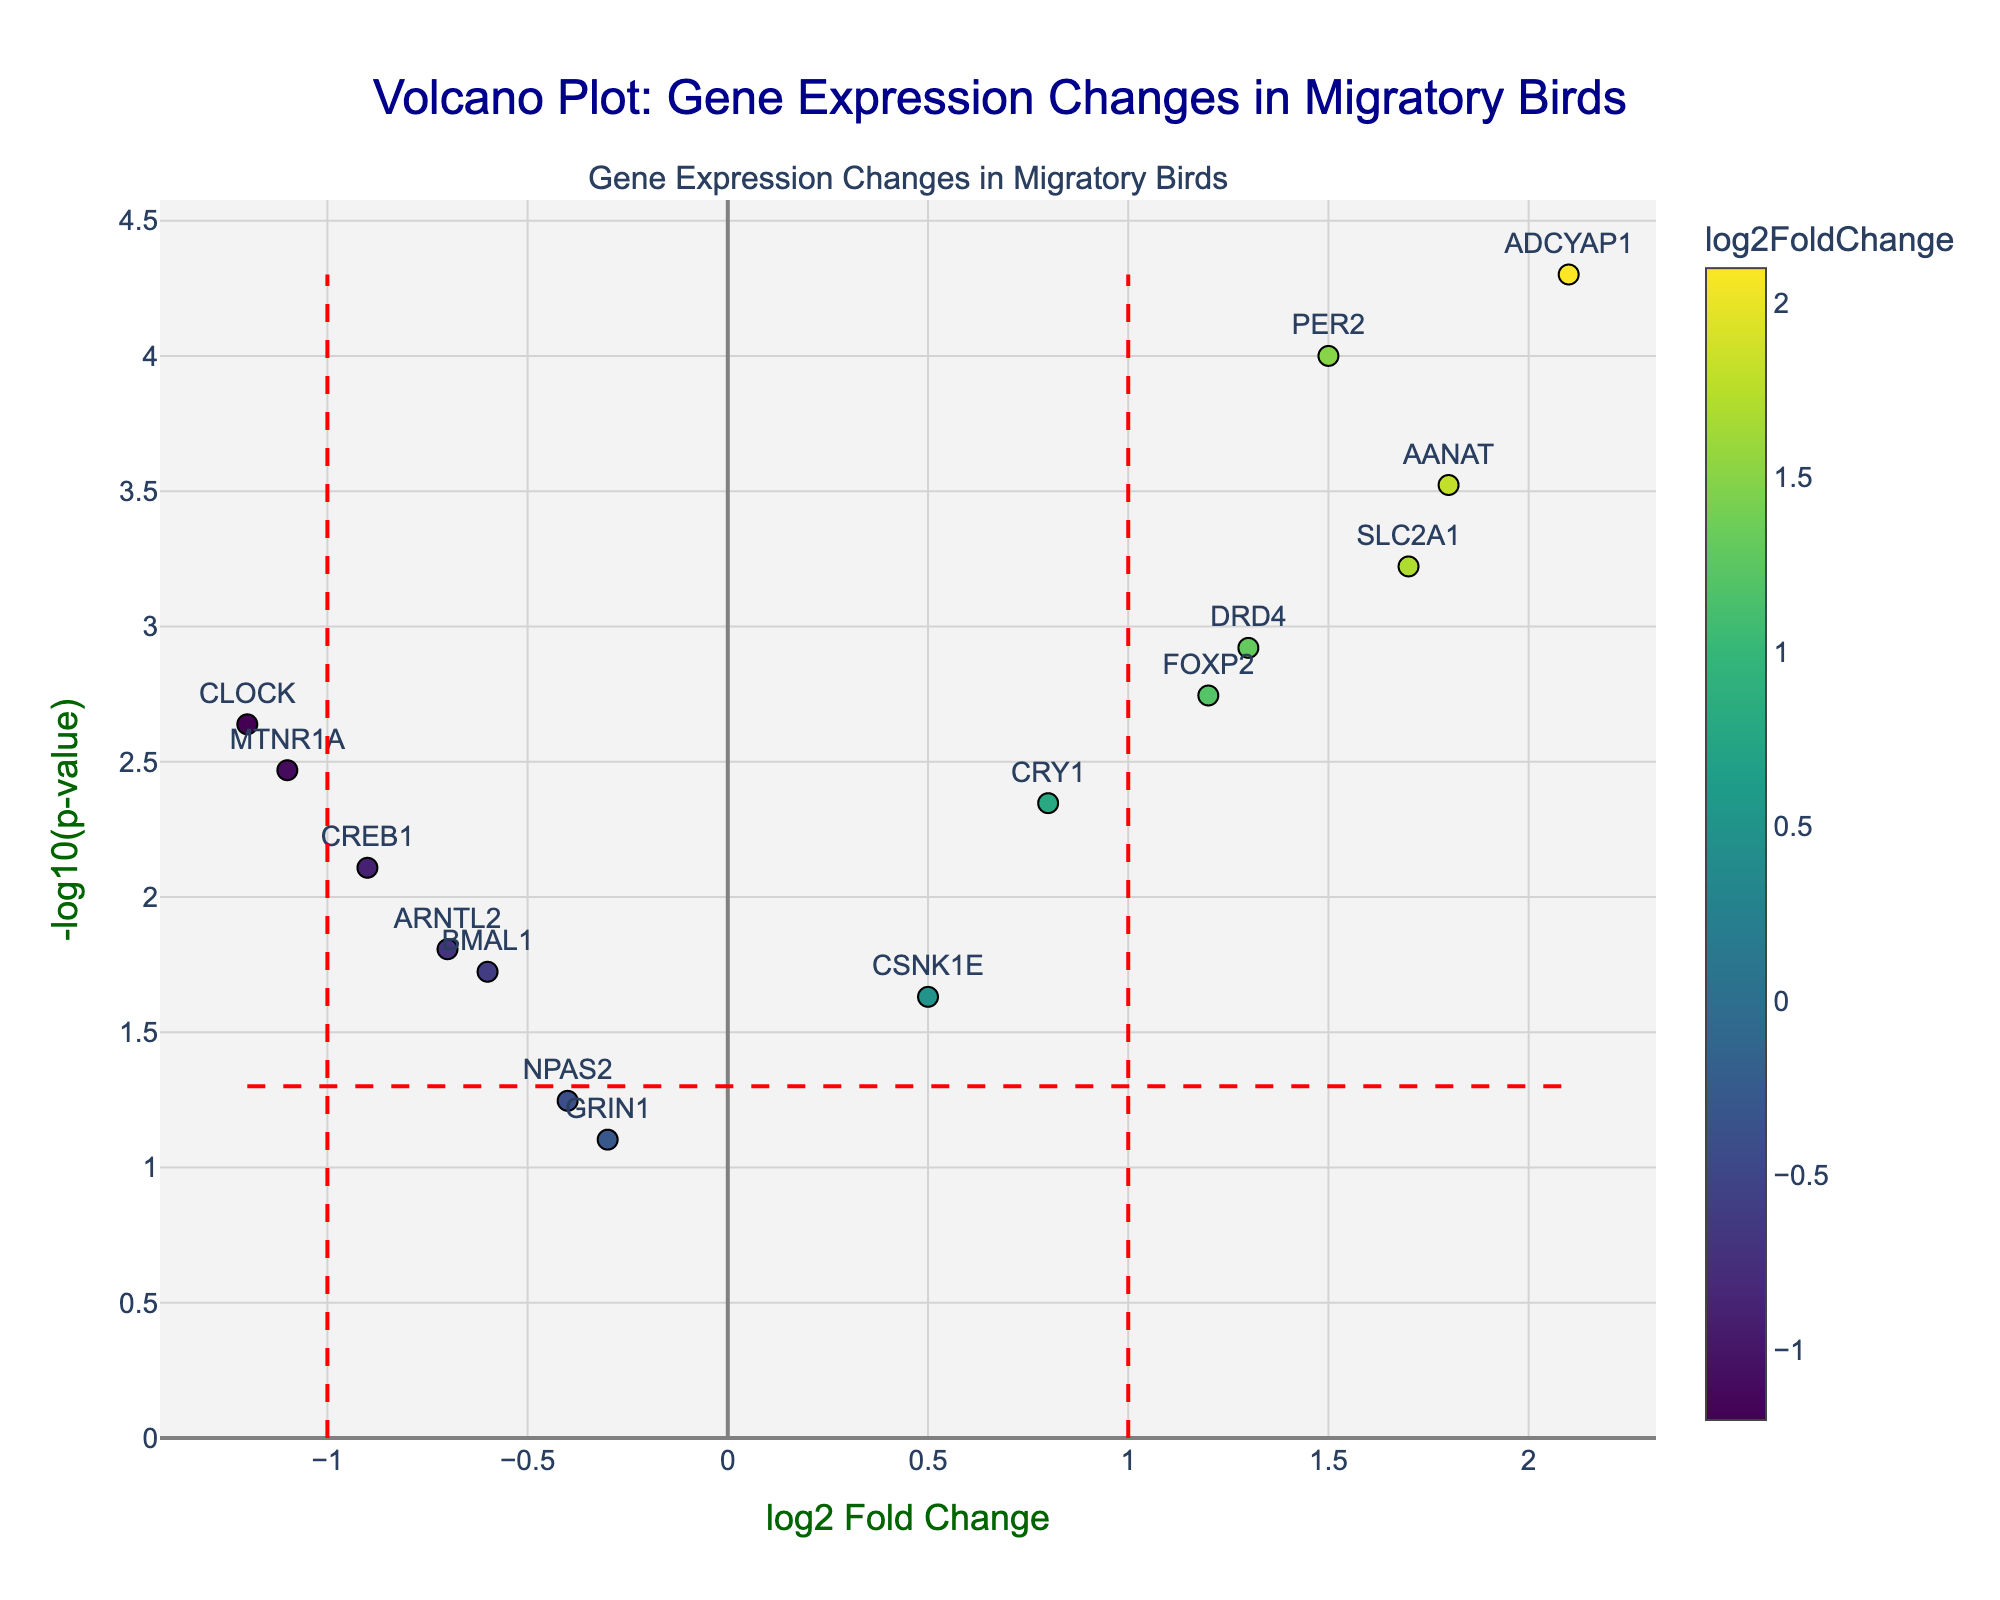How many genes have a log2 fold change greater than 1 or less than -1? Identify the data points where log2 fold change (x-axis) is either greater than 1 or less than -1. There are two vertical dashed lines at log2 fold changes of -1 and 1, making it easy to count the points outside of these lines. There are 6 genes satisfying this condition.
Answer: 6 What is the significance threshold shown in the plot? The horizontal dashed red line indicates the significance threshold, which corresponds to a -log10(p-value) of 1.3.
Answer: -log10(p-value) = 1.3 Which gene has the highest log2 fold change? Look for the gene with the highest value on the x-axis. The gene ADCYAP1 has the highest log2 fold change of 2.1.
Answer: ADCYAP1 Which gene has the lowest p-value? The lowest p-value corresponds to the highest -log10(p-value) on the y-axis. The gene ADCYAP1 has the highest -log10(p-value), indicating it has the lowest p-value.
Answer: ADCYAP1 How many genes have p-values less than 0.05? The horizontal significance threshold at -log10(p-value) = 1.3 indicates p-value = 0.05. Count the points above this line. There are 10 such data points above the horizontal threshold line.
Answer: 10 Which genes have both significant p-values (p-value < 0.05) and absolute log2 fold change > 1? Locate the data points above the horizontal dashed line (-log10(p-value) = 1.3) and outside the vertical dashed lines (log2 fold change = -1 and 1). These genes are PER2, ADCYAP1, DRD4, AANAT, and SLC2A1.
Answer: PER2, ADCYAP1, DRD4, AANAT, SLC2A1 What is the log2 fold change value of the gene with the second highest -log10(p-value)? Identify the gene with the second highest -log10(p-value) value on the y-axis, which is AANAT, and find its log2 fold change value, which is 1.8.
Answer: 1.8 Which genes are downregulated with significant p-values? Downregulated genes have negative log2 fold changes and significant p-values, meaning they are above the horizontal dashed line (-log10(p-value) = 1.3). These genes are CLOCK, BMAL1, CREB1, and MTNR1A.
Answer: CLOCK, BMAL1, CREB1, MTNR1A 